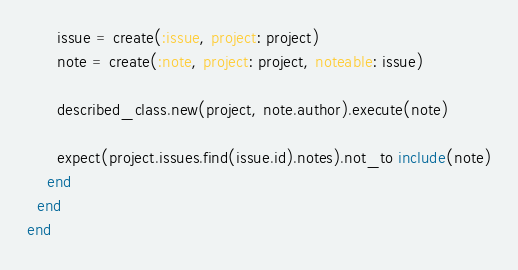<code> <loc_0><loc_0><loc_500><loc_500><_Ruby_>      issue = create(:issue, project: project)
      note = create(:note, project: project, noteable: issue)

      described_class.new(project, note.author).execute(note)

      expect(project.issues.find(issue.id).notes).not_to include(note)
    end
  end
end
</code> 